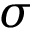<formula> <loc_0><loc_0><loc_500><loc_500>\sigma</formula> 